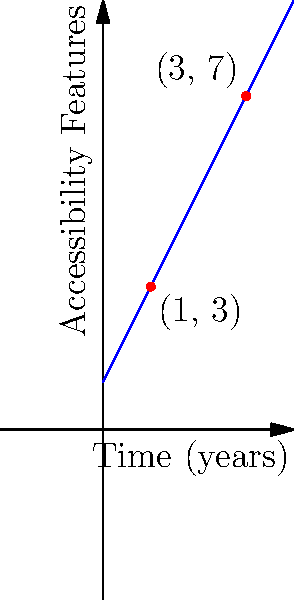A company is tracking the implementation of accessibility features on their online platform over time. The graph shows the relationship between the number of accessibility features and years since the initiative began. Given the points (1, 3) and (3, 7) on the line, calculate the slope of the line. What does this slope represent in the context of accessibility features? To calculate the slope of the line, we'll use the slope formula:

$$ \text{slope} = m = \frac{y_2 - y_1}{x_2 - x_1} $$

Where $(x_1, y_1)$ is the first point and $(x_2, y_2)$ is the second point.

Given points: (1, 3) and (3, 7)

Step 1: Identify the coordinates
$x_1 = 1$, $y_1 = 3$
$x_2 = 3$, $y_2 = 7$

Step 2: Apply the slope formula
$$ m = \frac{7 - 3}{3 - 1} = \frac{4}{2} = 2 $$

Step 3: Interpret the result
The slope of 2 means that for each year that passes (x-axis), the number of accessibility features (y-axis) increases by 2.

In the context of accessibility features, this slope represents the rate at which new accessibility features are being added to the platform each year. A slope of 2 indicates that the company is consistently adding 2 new accessibility features per year to their online platform.
Answer: Slope = 2, representing 2 new accessibility features added per year. 